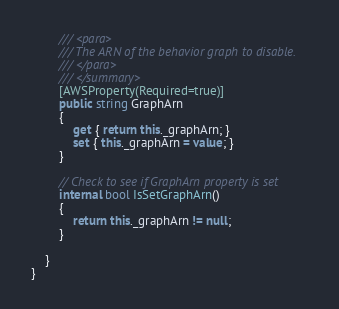Convert code to text. <code><loc_0><loc_0><loc_500><loc_500><_C#_>        /// <para>
        /// The ARN of the behavior graph to disable.
        /// </para>
        /// </summary>
        [AWSProperty(Required=true)]
        public string GraphArn
        {
            get { return this._graphArn; }
            set { this._graphArn = value; }
        }

        // Check to see if GraphArn property is set
        internal bool IsSetGraphArn()
        {
            return this._graphArn != null;
        }

    }
}</code> 